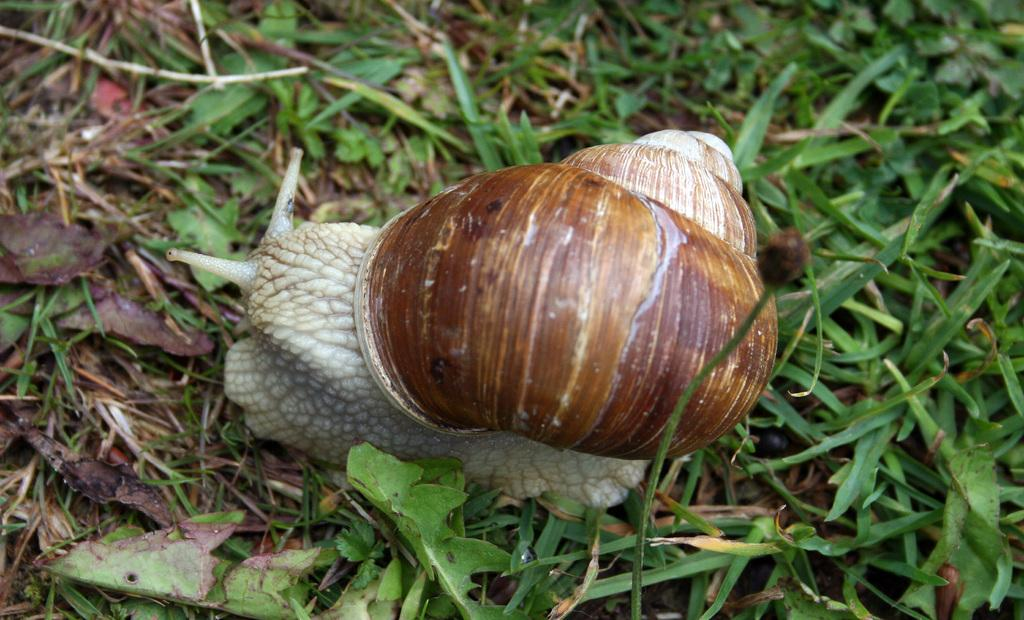What is the main subject of the picture? The main subject of the picture is a snail. What type of environment is depicted in the picture? There is grass on the ground in the picture, suggesting a natural setting. How many flames can be seen surrounding the snail in the picture? There are no flames present in the image; it features a snail in a grassy environment. What type of animal is the mother of the snail in the picture? There is no indication of a mother snail or any other animals in the image. 